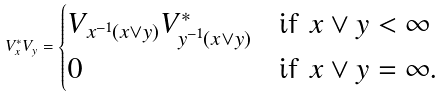<formula> <loc_0><loc_0><loc_500><loc_500>V _ { x } ^ { * } V _ { y } = \begin{cases} V _ { x ^ { - 1 } ( x \vee y ) } V _ { y ^ { - 1 } ( x \vee y ) } ^ { * } & \text {if $x\vee y<\infty$} \\ 0 & \text {if $x\vee y=\infty$.} \end{cases}</formula> 